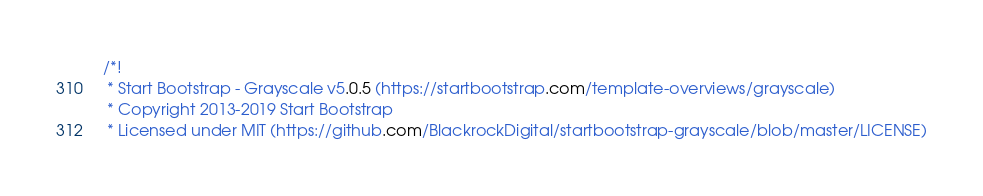<code> <loc_0><loc_0><loc_500><loc_500><_CSS_>/*!
 * Start Bootstrap - Grayscale v5.0.5 (https://startbootstrap.com/template-overviews/grayscale)
 * Copyright 2013-2019 Start Bootstrap
 * Licensed under MIT (https://github.com/BlackrockDigital/startbootstrap-grayscale/blob/master/LICENSE)</code> 